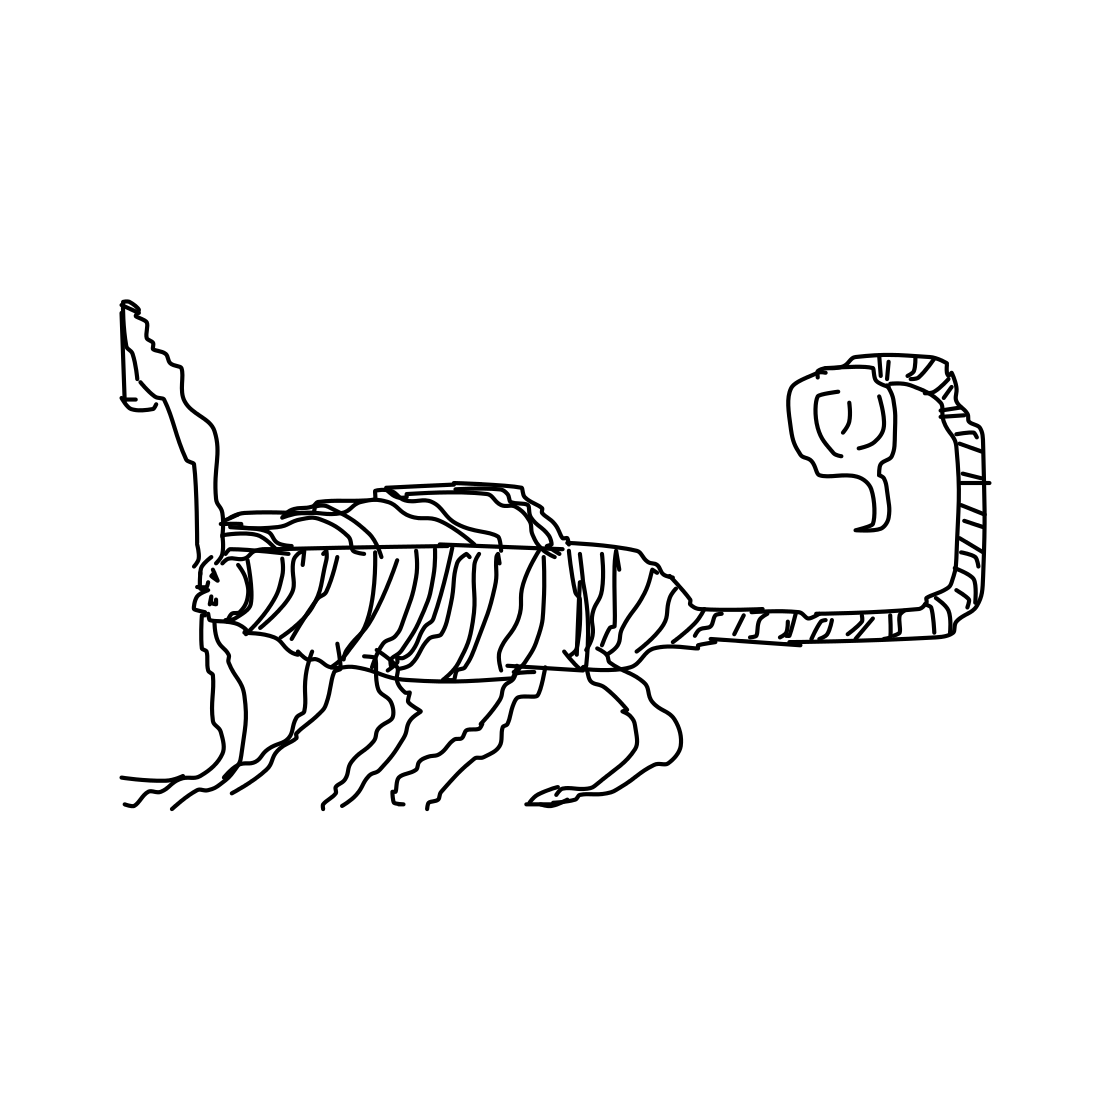Can you invent a short story involving the creature in the image? In a whimsical world where animals are not bound by their conventional shapes, there lived a unique creature with the grace of a feline and the strength of a horse. It roamed the expansive meadows, its striped coat shimmering under the sun. Each day was an adventure, as it encountered creatures with equally fantastical forms. Together, they reveled in the beauty of their diverse world, showing that creativity knows no bounds. 